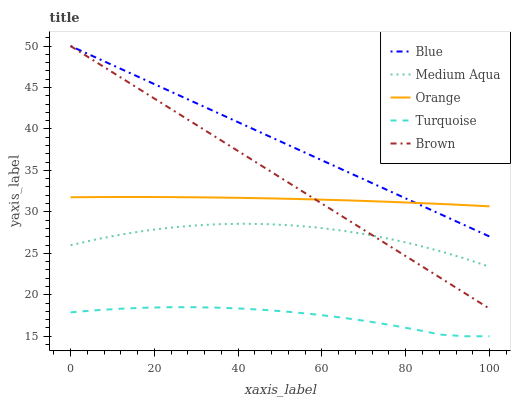Does Turquoise have the minimum area under the curve?
Answer yes or no. Yes. Does Blue have the maximum area under the curve?
Answer yes or no. Yes. Does Orange have the minimum area under the curve?
Answer yes or no. No. Does Orange have the maximum area under the curve?
Answer yes or no. No. Is Brown the smoothest?
Answer yes or no. Yes. Is Medium Aqua the roughest?
Answer yes or no. Yes. Is Orange the smoothest?
Answer yes or no. No. Is Orange the roughest?
Answer yes or no. No. Does Turquoise have the lowest value?
Answer yes or no. Yes. Does Orange have the lowest value?
Answer yes or no. No. Does Brown have the highest value?
Answer yes or no. Yes. Does Orange have the highest value?
Answer yes or no. No. Is Medium Aqua less than Orange?
Answer yes or no. Yes. Is Orange greater than Turquoise?
Answer yes or no. Yes. Does Blue intersect Orange?
Answer yes or no. Yes. Is Blue less than Orange?
Answer yes or no. No. Is Blue greater than Orange?
Answer yes or no. No. Does Medium Aqua intersect Orange?
Answer yes or no. No. 